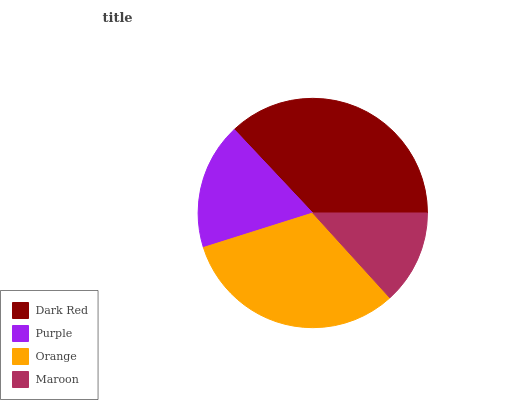Is Maroon the minimum?
Answer yes or no. Yes. Is Dark Red the maximum?
Answer yes or no. Yes. Is Purple the minimum?
Answer yes or no. No. Is Purple the maximum?
Answer yes or no. No. Is Dark Red greater than Purple?
Answer yes or no. Yes. Is Purple less than Dark Red?
Answer yes or no. Yes. Is Purple greater than Dark Red?
Answer yes or no. No. Is Dark Red less than Purple?
Answer yes or no. No. Is Orange the high median?
Answer yes or no. Yes. Is Purple the low median?
Answer yes or no. Yes. Is Purple the high median?
Answer yes or no. No. Is Dark Red the low median?
Answer yes or no. No. 